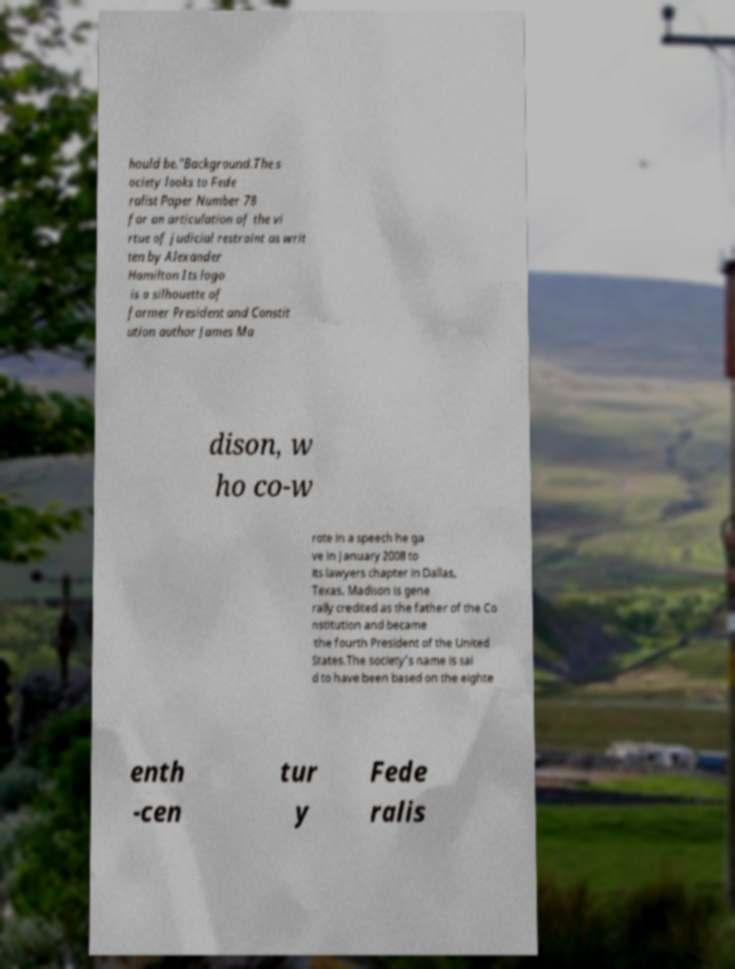Can you accurately transcribe the text from the provided image for me? hould be."Background.The s ociety looks to Fede ralist Paper Number 78 for an articulation of the vi rtue of judicial restraint as writ ten by Alexander Hamilton Its logo is a silhouette of former President and Constit ution author James Ma dison, w ho co-w rote in a speech he ga ve in January 2008 to its lawyers chapter in Dallas, Texas. Madison is gene rally credited as the father of the Co nstitution and became the fourth President of the United States.The society's name is sai d to have been based on the eighte enth -cen tur y Fede ralis 